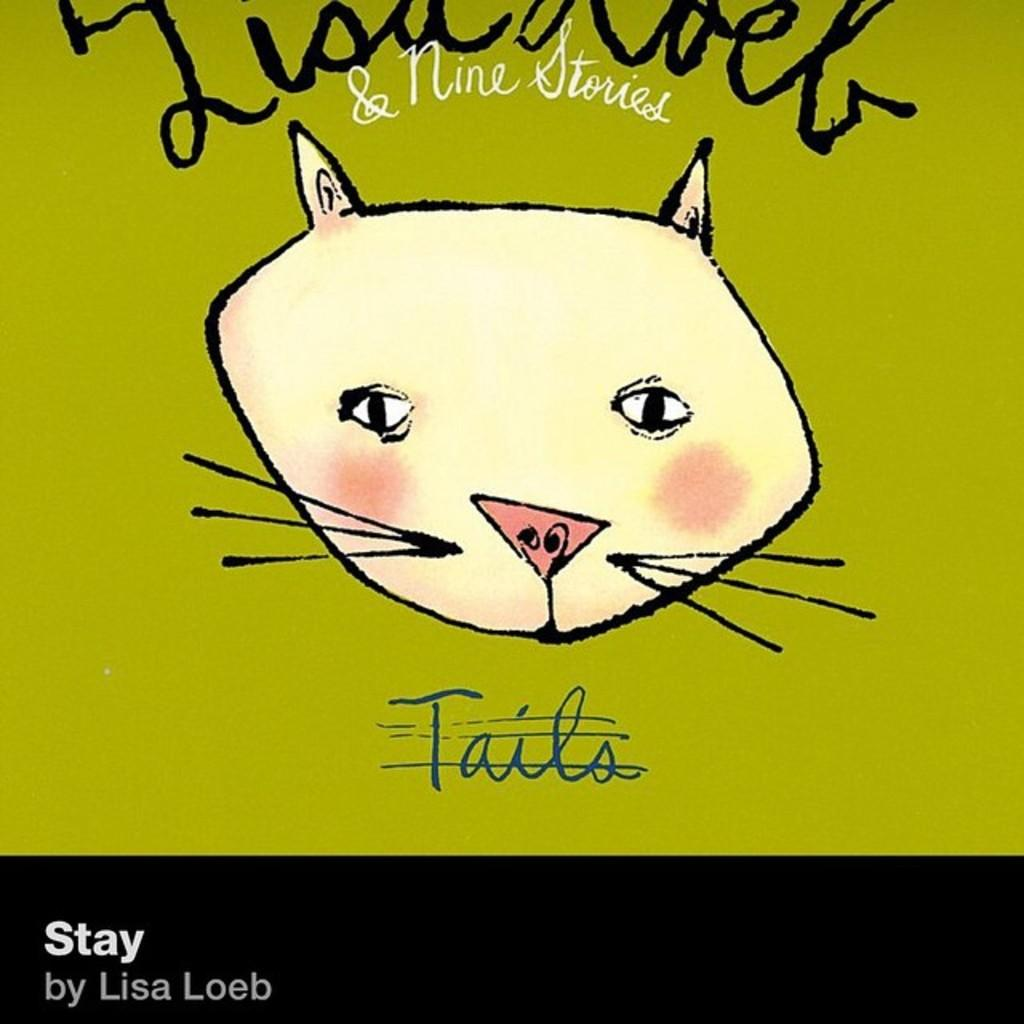What is depicted in the image? There is a drawing of an animal's face in the image. Can you describe the text on the drawing? There is text written on the drawing. What type of paper is the cactus made of in the image? There is no cactus present in the image; it features a drawing of an animal's face with text. 